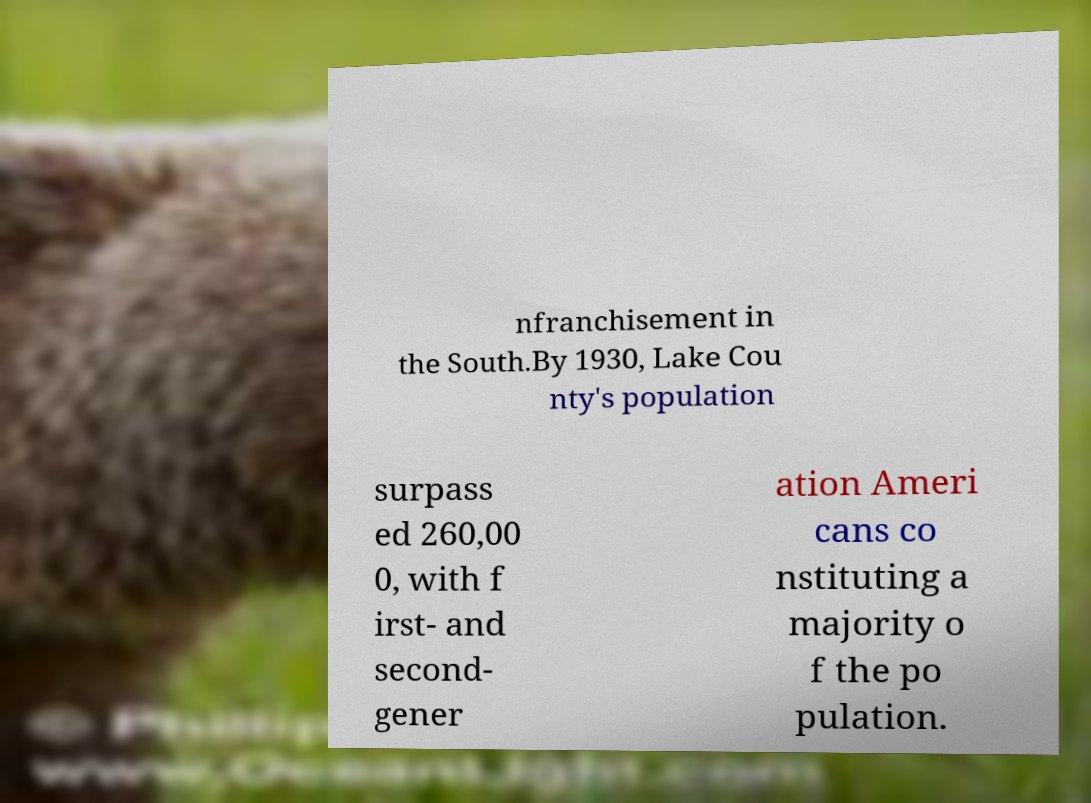There's text embedded in this image that I need extracted. Can you transcribe it verbatim? nfranchisement in the South.By 1930, Lake Cou nty's population surpass ed 260,00 0, with f irst- and second- gener ation Ameri cans co nstituting a majority o f the po pulation. 